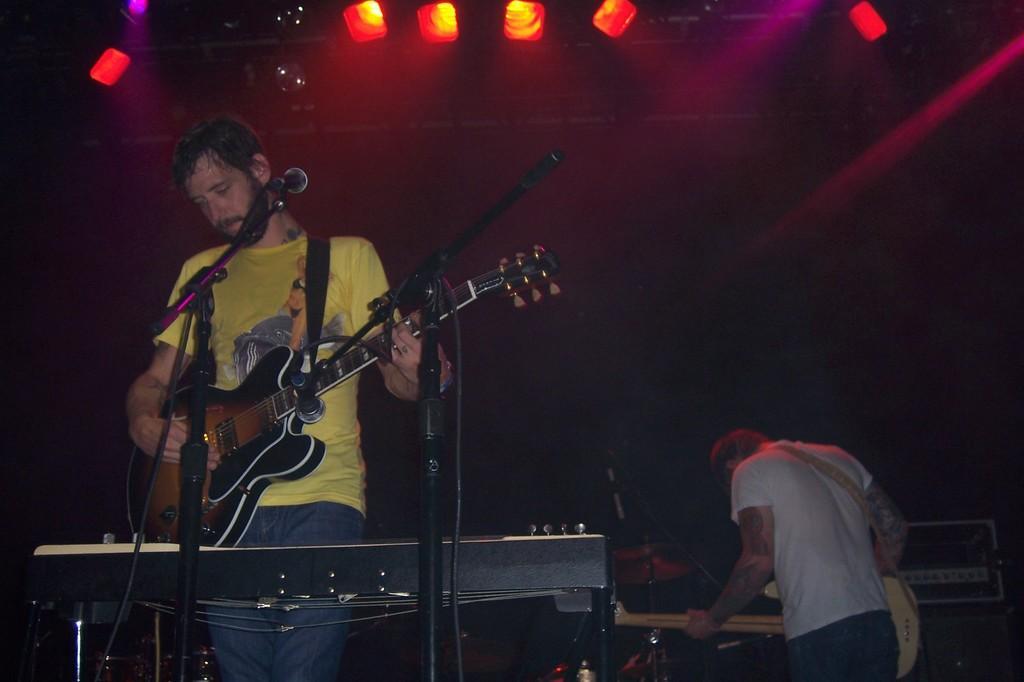Could you give a brief overview of what you see in this image? The person wearing yellow is playing guitar in front of mic and there is another person in the background holding guitar. 